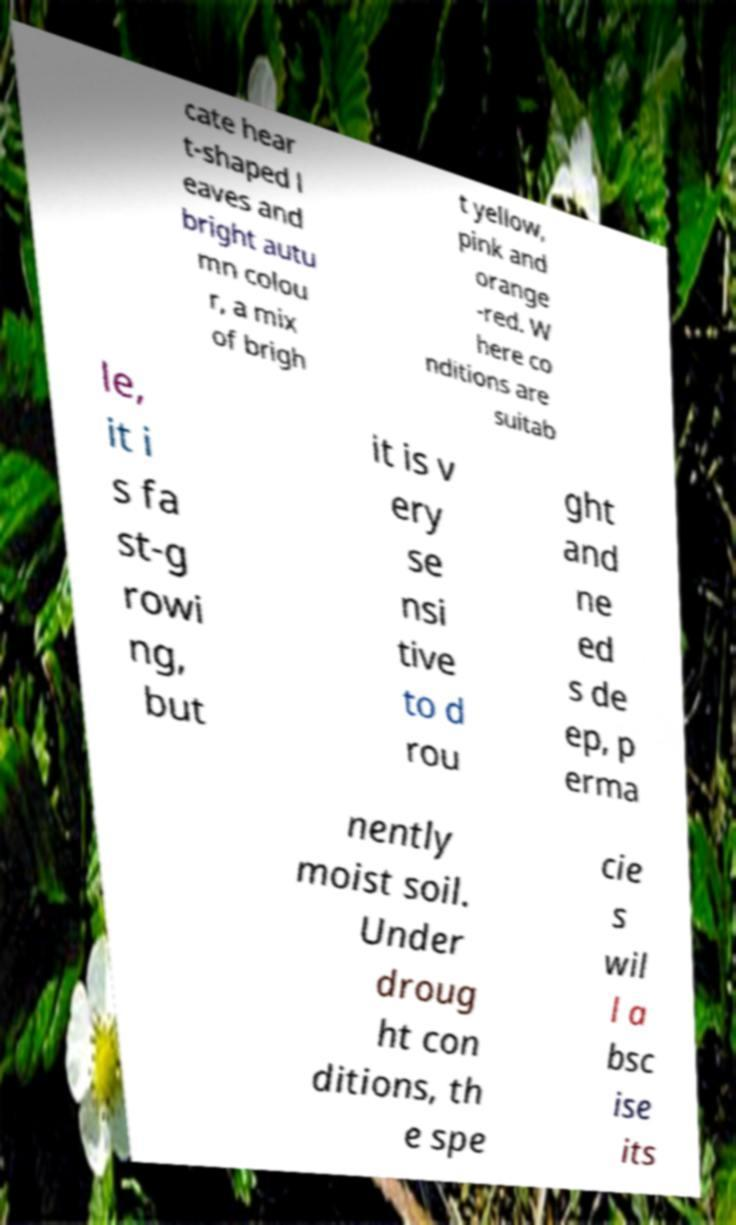I need the written content from this picture converted into text. Can you do that? cate hear t-shaped l eaves and bright autu mn colou r, a mix of brigh t yellow, pink and orange -red. W here co nditions are suitab le, it i s fa st-g rowi ng, but it is v ery se nsi tive to d rou ght and ne ed s de ep, p erma nently moist soil. Under droug ht con ditions, th e spe cie s wil l a bsc ise its 